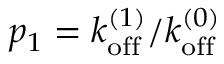<formula> <loc_0><loc_0><loc_500><loc_500>p _ { 1 } = k _ { o f f } ^ { ( 1 ) } / k _ { o f f } ^ { ( 0 ) }</formula> 